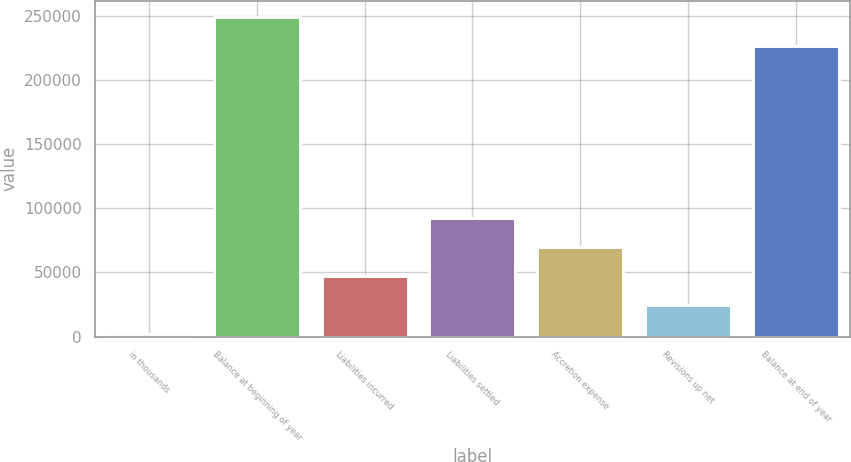<chart> <loc_0><loc_0><loc_500><loc_500><bar_chart><fcel>in thousands<fcel>Balance at beginning of year<fcel>Liabilities incurred<fcel>Liabilities settled<fcel>Accretion expense<fcel>Revisions up net<fcel>Balance at end of year<nl><fcel>2014<fcel>249187<fcel>47258<fcel>92502<fcel>69880<fcel>24636<fcel>226565<nl></chart> 